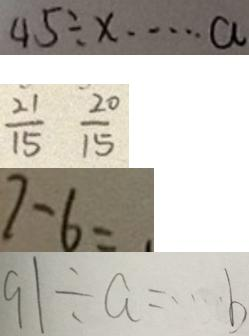<formula> <loc_0><loc_0><loc_500><loc_500>4 5 \div x \cdots a 
 \frac { 2 1 } { 1 5 } \frac { 2 0 } { 1 5 } 
 7 - 6 = 
 9 1 \div a = \cdots b</formula> 